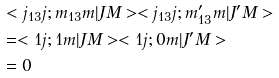Convert formula to latex. <formula><loc_0><loc_0><loc_500><loc_500>& < j _ { 1 3 } j ; m _ { 1 3 } m | J M > < j _ { 1 3 } j ; m ^ { \prime } _ { 1 3 } m | J ^ { \prime } M > \\ & = < 1 j ; 1 m | J M > < 1 j ; 0 m | J ^ { \prime } M > \\ & = 0</formula> 